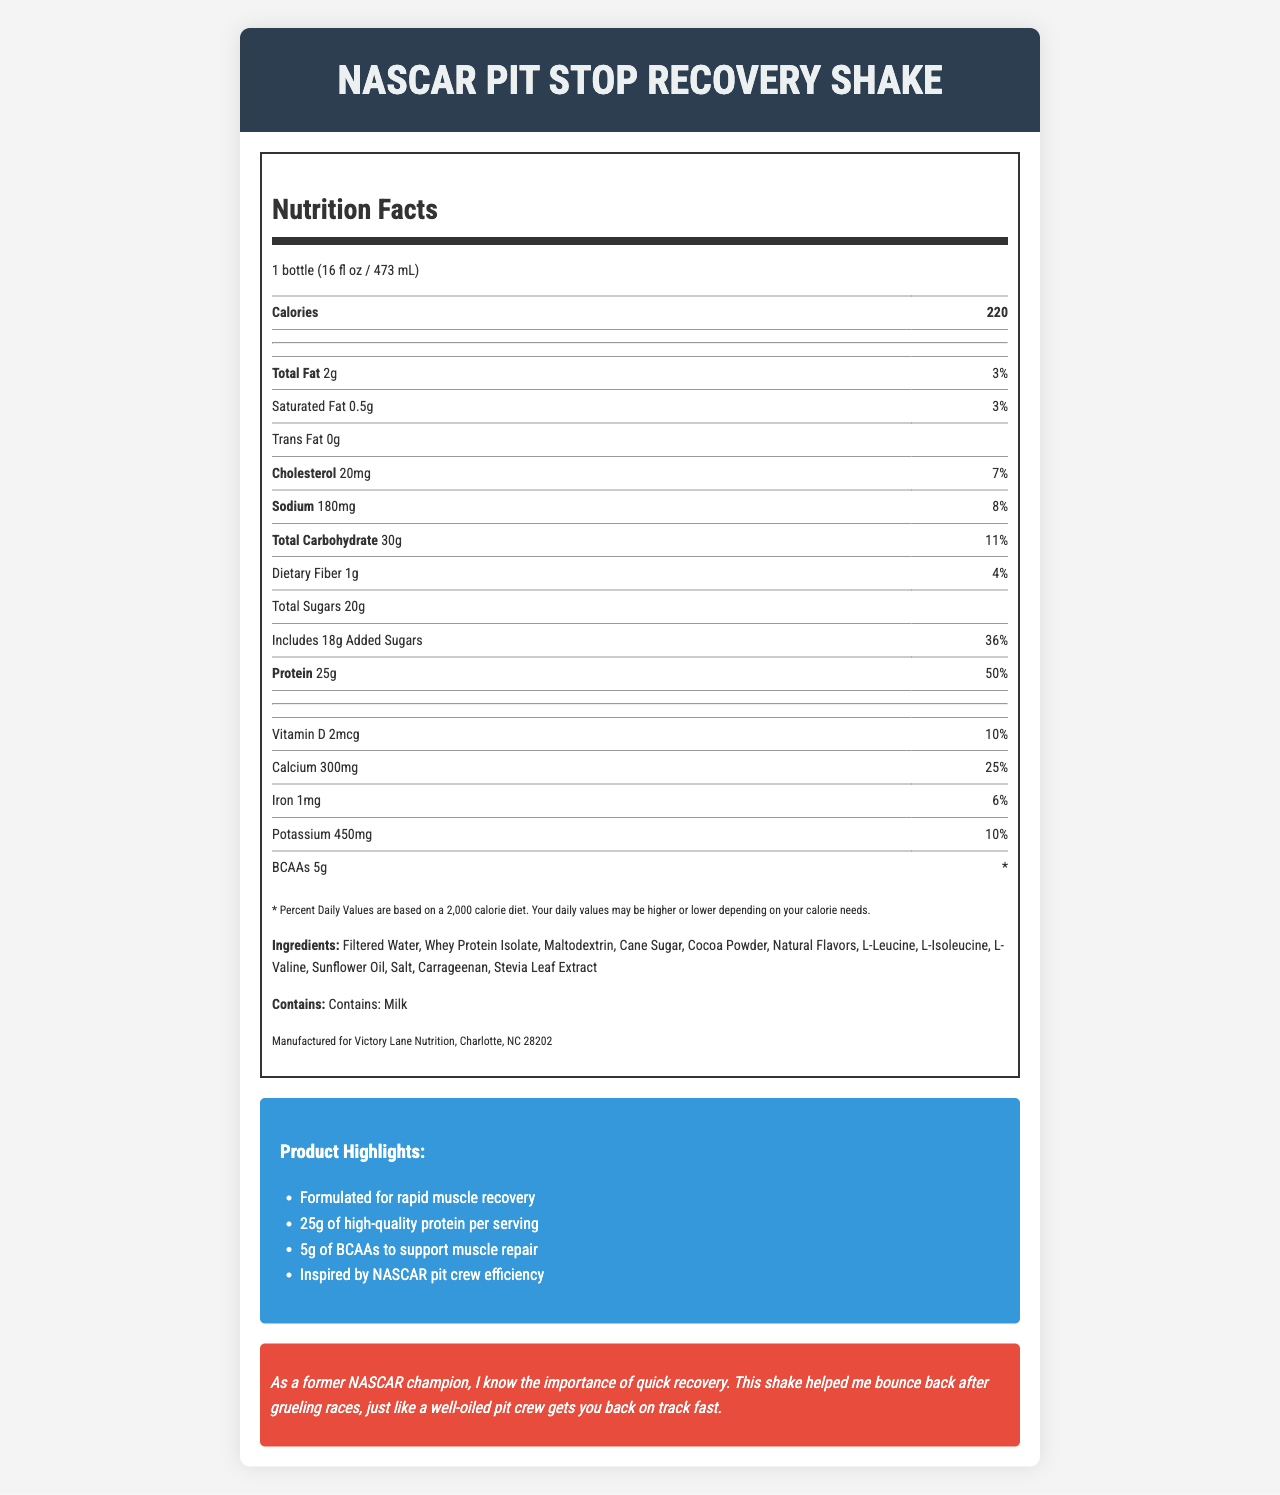what is the serving size of the NASCAR Pit Stop Recovery Shake? The serving size is listed at the top of the Nutrition Facts section.
Answer: 1 bottle (16 fl oz / 473 mL) What percentage of the Daily Value is the protein content? The document shows that the shake contains 25g of protein, which is 50% of the Daily Value.
Answer: 50% List all the types of fats and their amounts found in the shake. The Nutrition Facts label breaks down the fats into Total Fat, Saturated Fat, and Trans Fat.
Answer: Total Fat: 2g, Saturated Fat: 0.5g, Trans Fat: 0g What is the main allergen present in the NASCAR Pit Stop Recovery Shake? The allergens section explicitly mentions "Contains: Milk."
Answer: Milk How much added sugar is in this recovery shake? The amount of added sugars is listed under the Total Sugars section in the Nutrition Facts.
Answer: 18g For which type of diet are the Percent Daily Values based? A. 1,500 calorie diet B. 2,000 calorie diet C. 2,500 calorie diet The disclaimer at the bottom of the Nutrition Facts label mentions that the Percent Daily Values are based on a 2,000 calorie diet.
Answer: B. 2,000 calorie diet What ingredient is likely to give the product its chocolate flavor? A. Cocoa Powder B. Maltodextrin C. Stevia Leaf Extract Among the ingredients listed, Cocoa Powder is the one most commonly associated with a chocolate flavor.
Answer: A. Cocoa Powder Does the NASCAR Pit Stop Recovery Shake contain any cholesterol? The label states the shake contains 20mg of cholesterol.
Answer: Yes Explain the main idea of the document. The document details the nutritional content, serving size, ingredients, and other relevant consumer information including allergen warnings and manufacturer details. It also emphasizes the shake's benefits for muscle recovery and includes a personalized message aimed at athletes.
Answer: The document provides detailed nutrition information about a post-workout recovery shake called the NASCAR Pit Stop Recovery Shake, highlighting its protein, BCAAs, ingredients, and allergen information. How many calories are in the entire container? The container only holds one serving, and each serving contains 220 calories.
Answer: 220 calories What manufacturing information is provided on the label? The manufacturer info is listed at the bottom of the Nutrition Facts section.
Answer: Manufactured for Victory Lane Nutrition, Charlotte, NC 28202 How many grams of sodium are in the shake? The label lists the sodium content in milligrams (180mg), but it does not provide information in grams.
Answer: Cannot be determined What type of oils is used in the ingredients? Sunflower Oil is listed in the ingredients section of the label.
Answer: Sunflower Oil 